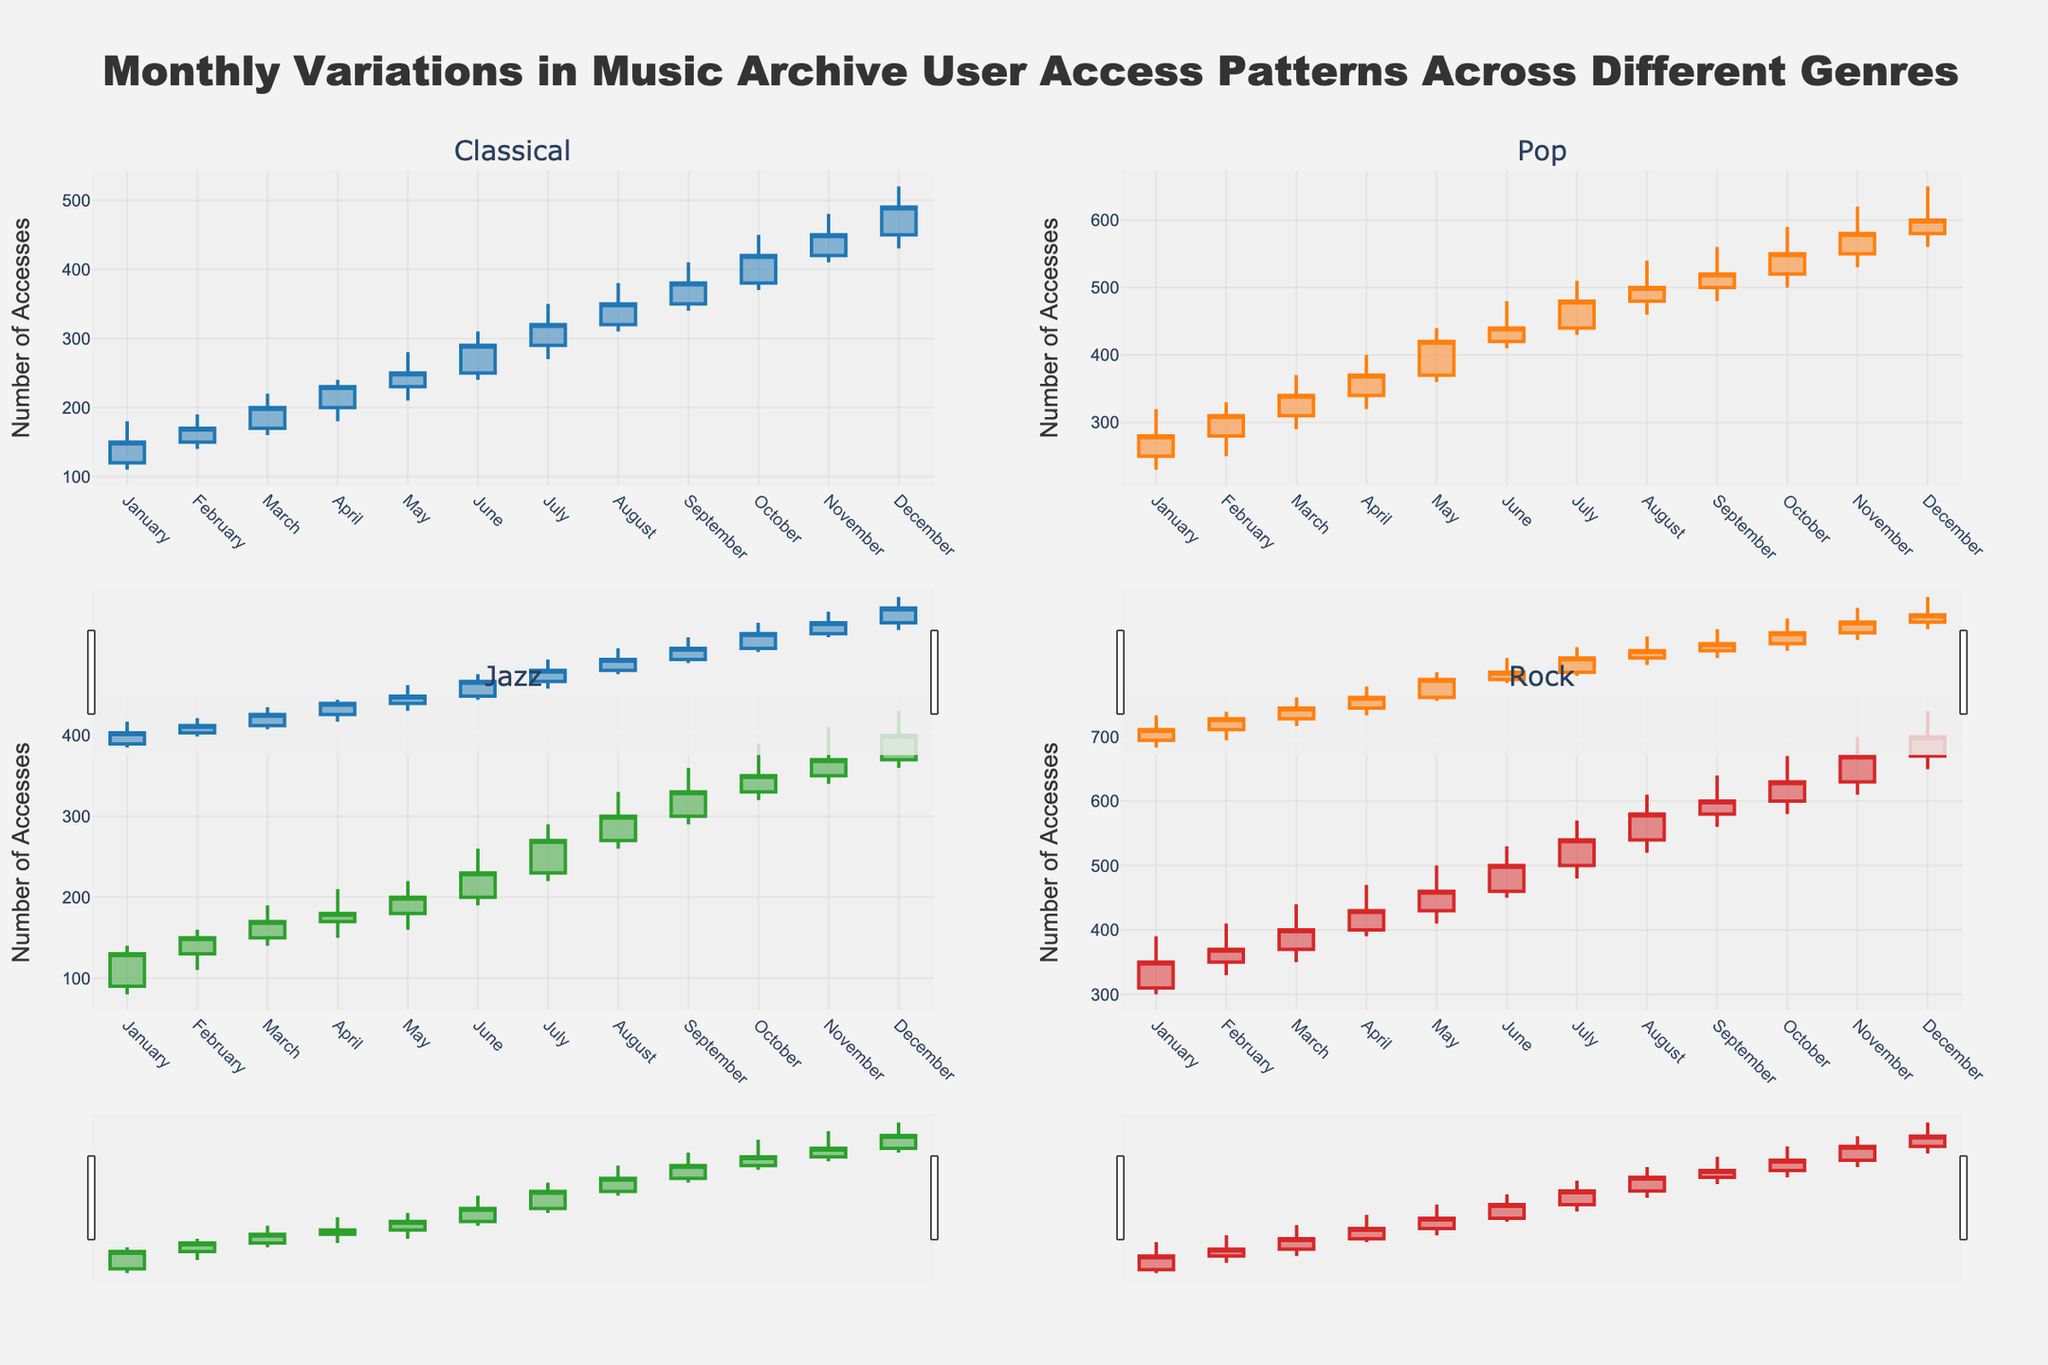Which genre had the highest peak user access in December? In December, Rock's high value is the highest among all genres at 740.
Answer: Rock What was the lowest user access for Jazz in October? For Jazz in October, the low value is seen at 320.
Answer: 320 Comparing January and February, which month had a higher closing user access for Pop? In January, Pop had a closing value of 280, whereas in February, it was 310. Therefore, February had a higher closing user access.
Answer: February What's the average closing user access for Classical genre in Q1 (January to March)? The closing values for Classical in January, February, and March are 150, 170, and 200, respectively. The average is (150 + 170 + 200)/3 = 173.33.
Answer: 173.33 Which genre shows a consistently increasing trend in user access from January to April? By examining the closing values from January to April for each genre:
- Classical: 150, 170, 200, 230
- Pop: 280, 310, 340, 370
- Jazz: 130, 150, 170, 180
- Rock: 350, 370, 400, 430
All genres show an increasing trend during this period.
Answer: Classical, Pop, Jazz, Rock What is the median high value of user access for Rock from June to August? The high values for Rock in June, July, and August are 530, 570, and 610, respectively. The median is 570.
Answer: 570 Which month had the highest user access for all genres combined in the "low" values? Summing the "low" values for all genres for each month, we find that December has the highest combined value with 1600 (430 + 560 + 360 + 650).
Answer: December What was the difference in closing user access for Rock between July and August? For Rock, the closing values in July and August are 540 and 580 respectively. The difference is 580 - 540 = 40.
Answer: 40 For the Jazz genre, which month had the smallest range of user access? The range of user access is High - Low. Comparing the ranges for Jazz:
- January: 140 - 80 = 60
- February: 160 - 110 = 50
- March: 190 - 140 = 50
- April: 210 - 150 = 60
- May: 220 - 160 = 60
- June: 260 - 190 = 70
- July: 290 - 220 = 70
- August: 330 - 260 = 70
- September: 360 - 290 = 70
- October: 390 - 320 = 70
- November: 410 - 340 = 70
- December: 430 - 360 = 70
Both February and March had the smallest range of 50.
Answer: February, March What is the combined closing user access for Classical and Pop genres in September? The closing value for Classical in September is 380 and for Pop, it is 520. Combined, they sum to 380 + 520 = 900.
Answer: 900 